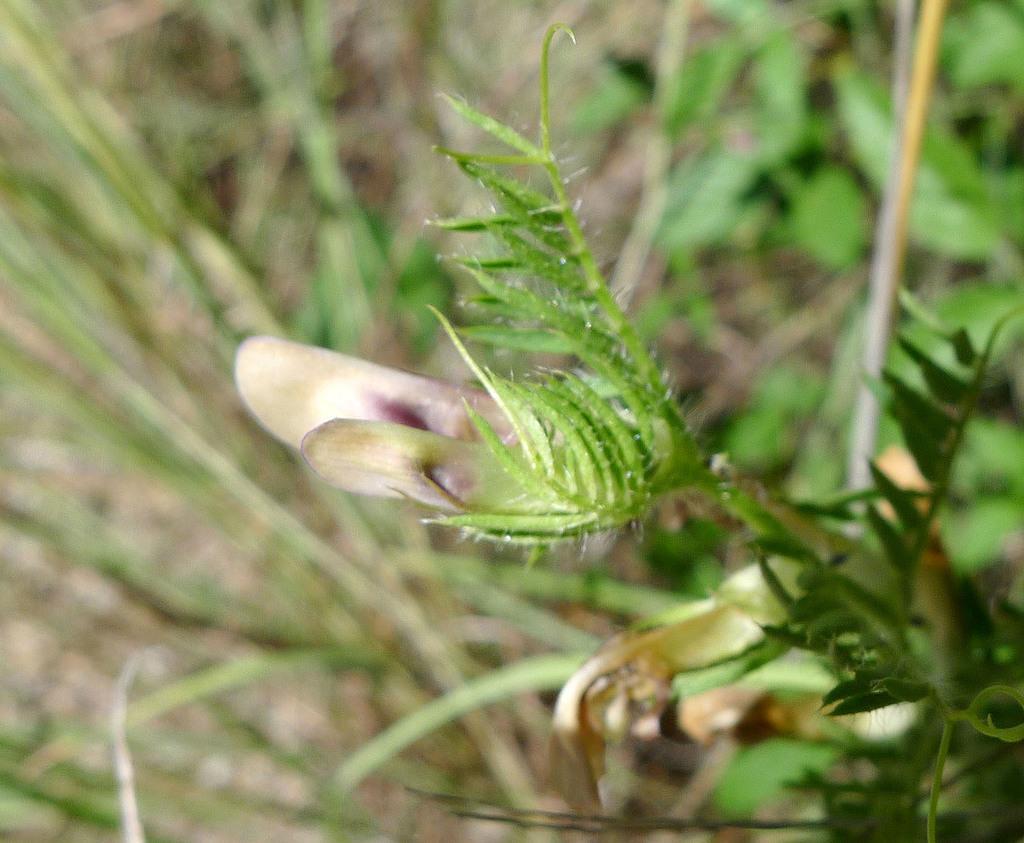Can you describe this image briefly? In this picture there is a flower plant in the center of the image and there is greenery in the background area of the image. 